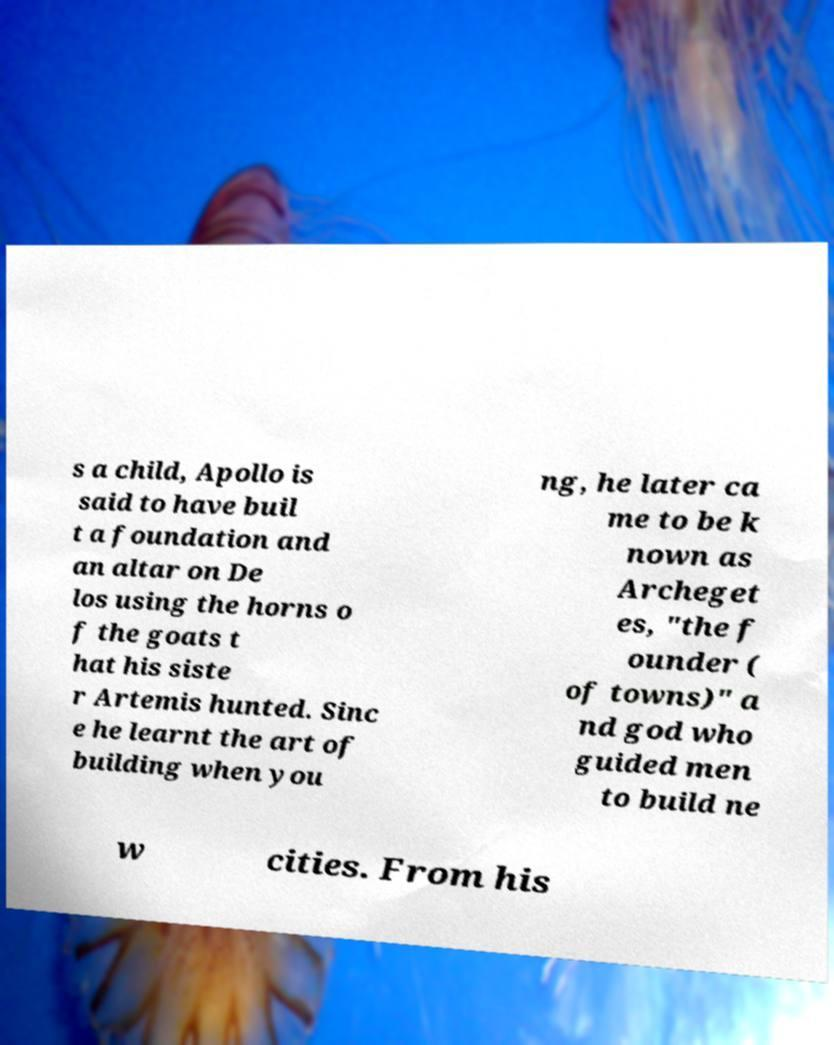Please read and relay the text visible in this image. What does it say? s a child, Apollo is said to have buil t a foundation and an altar on De los using the horns o f the goats t hat his siste r Artemis hunted. Sinc e he learnt the art of building when you ng, he later ca me to be k nown as Archeget es, "the f ounder ( of towns)" a nd god who guided men to build ne w cities. From his 